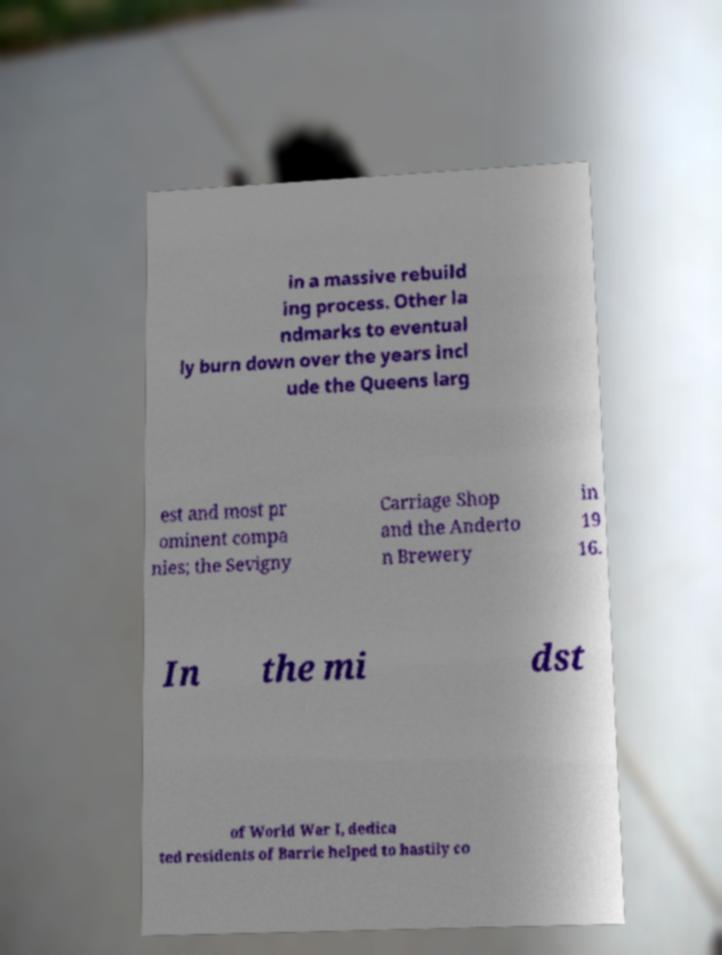Could you assist in decoding the text presented in this image and type it out clearly? in a massive rebuild ing process. Other la ndmarks to eventual ly burn down over the years incl ude the Queens larg est and most pr ominent compa nies; the Sevigny Carriage Shop and the Anderto n Brewery in 19 16. In the mi dst of World War I, dedica ted residents of Barrie helped to hastily co 